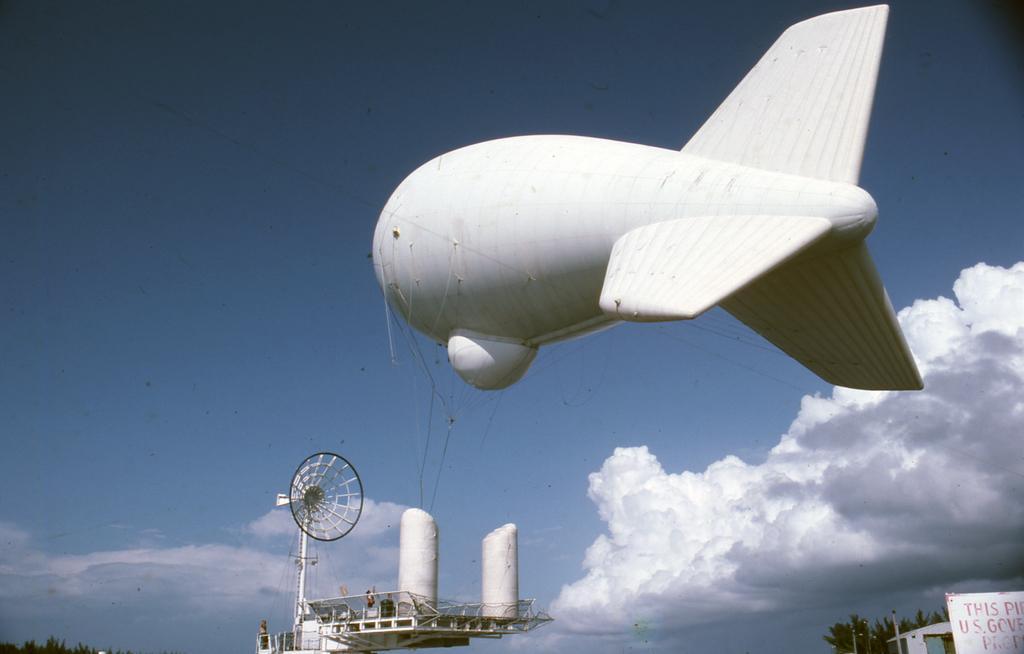In one or two sentences, can you explain what this image depicts? In this image there is antenna on the base beside that there are tunnels and air balloon in the sky with the shape of aeroplane. Beside that there are clouds on the sky. 